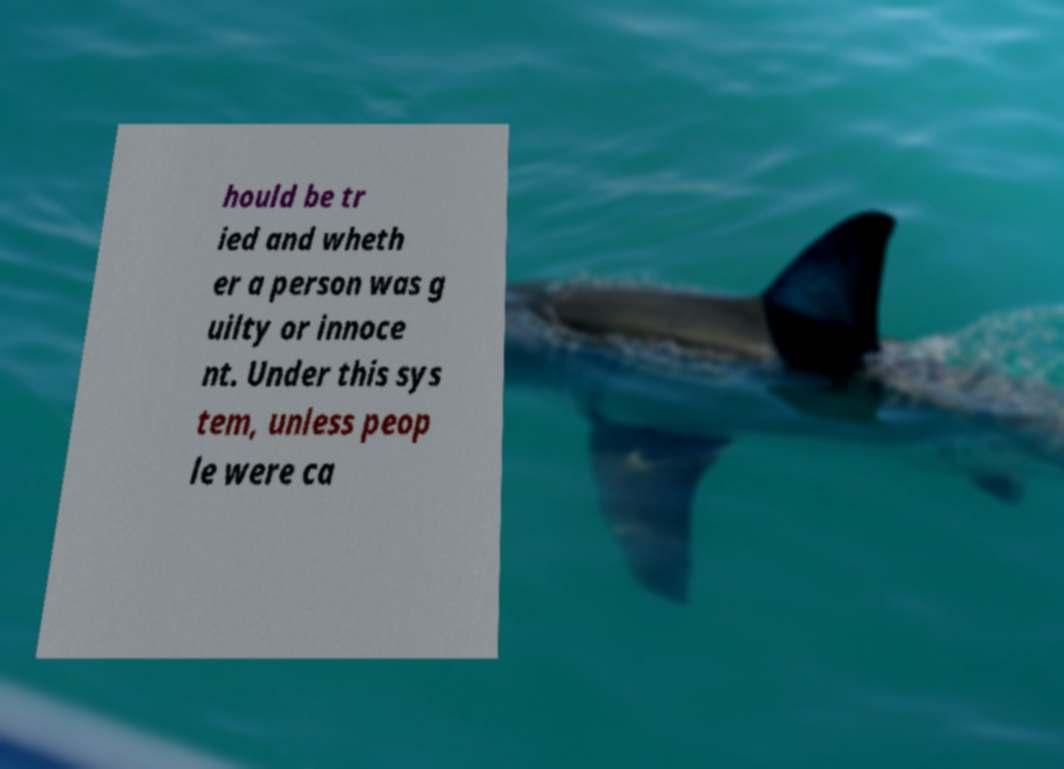Could you assist in decoding the text presented in this image and type it out clearly? hould be tr ied and wheth er a person was g uilty or innoce nt. Under this sys tem, unless peop le were ca 